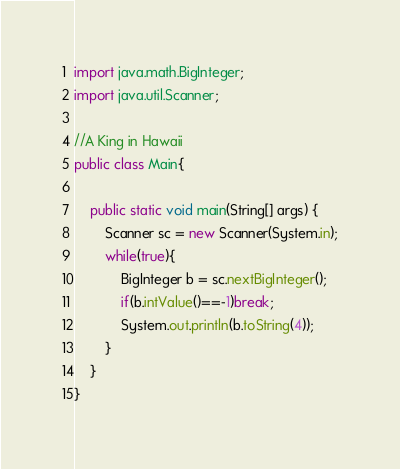<code> <loc_0><loc_0><loc_500><loc_500><_Java_>import java.math.BigInteger;
import java.util.Scanner;

//A King in Hawaii
public class Main{

	public static void main(String[] args) {
		Scanner sc = new Scanner(System.in);
		while(true){
			BigInteger b = sc.nextBigInteger();
			if(b.intValue()==-1)break;
			System.out.println(b.toString(4));
		}
	}
}</code> 